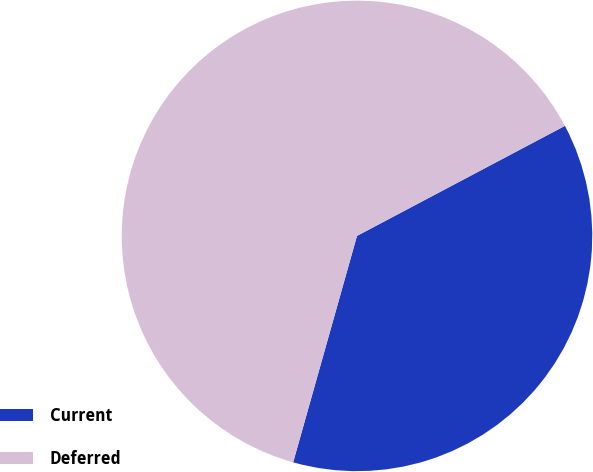Convert chart. <chart><loc_0><loc_0><loc_500><loc_500><pie_chart><fcel>Current<fcel>Deferred<nl><fcel>37.12%<fcel>62.88%<nl></chart> 